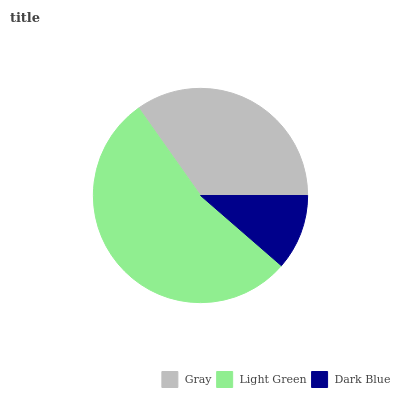Is Dark Blue the minimum?
Answer yes or no. Yes. Is Light Green the maximum?
Answer yes or no. Yes. Is Light Green the minimum?
Answer yes or no. No. Is Dark Blue the maximum?
Answer yes or no. No. Is Light Green greater than Dark Blue?
Answer yes or no. Yes. Is Dark Blue less than Light Green?
Answer yes or no. Yes. Is Dark Blue greater than Light Green?
Answer yes or no. No. Is Light Green less than Dark Blue?
Answer yes or no. No. Is Gray the high median?
Answer yes or no. Yes. Is Gray the low median?
Answer yes or no. Yes. Is Light Green the high median?
Answer yes or no. No. Is Dark Blue the low median?
Answer yes or no. No. 